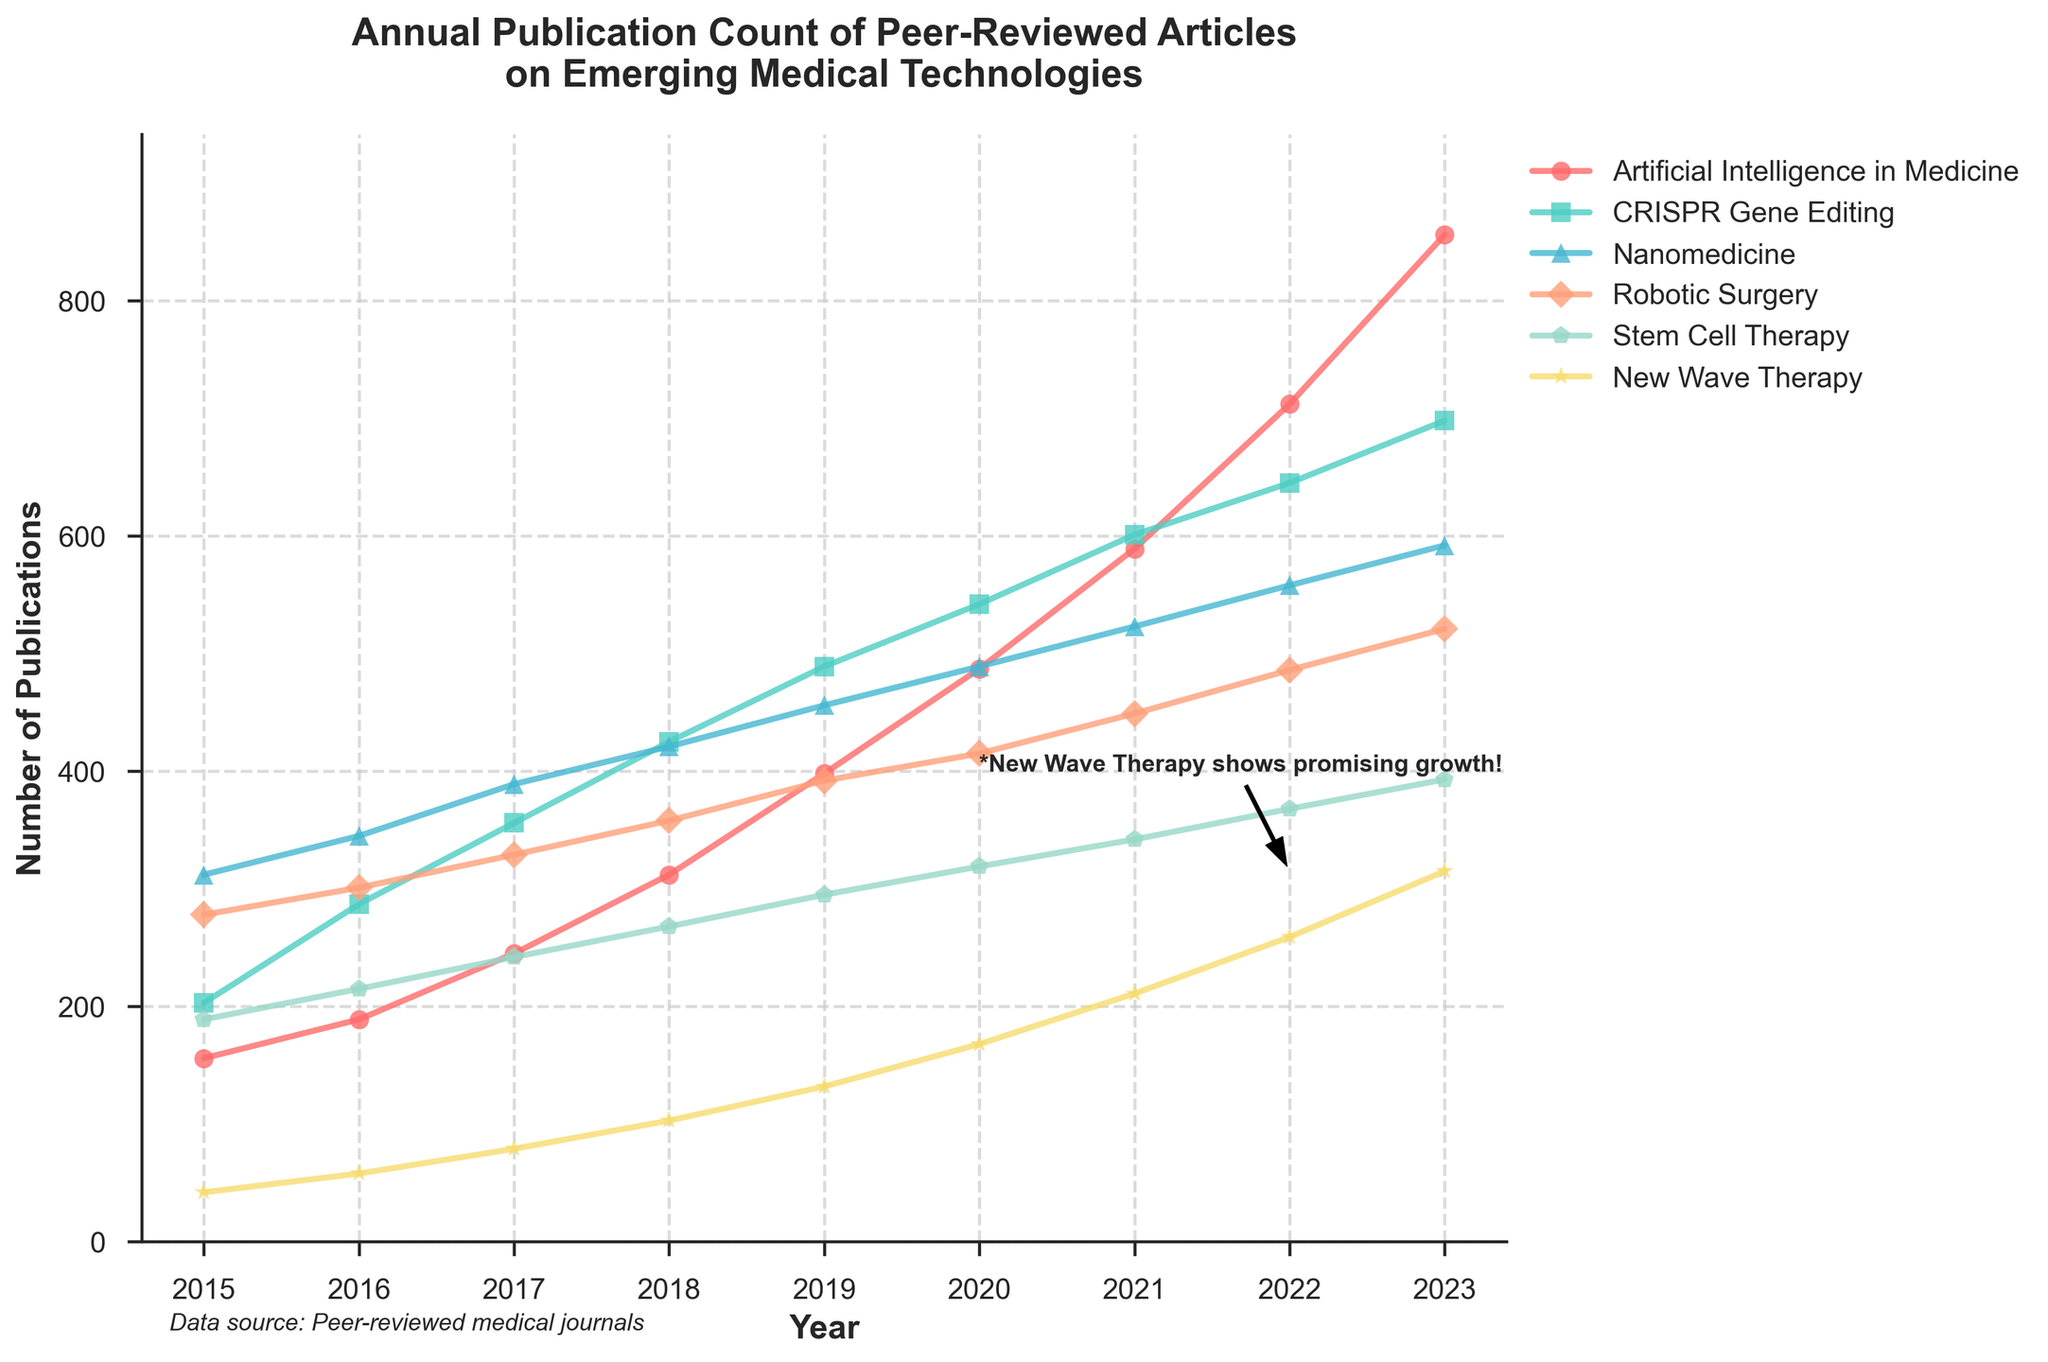What's the total number of publications in 2023 for all the technologies combined? To find the total, add the publication counts for all the technologies in the year 2023: 856 (AI in Medicine) + 698 (CRISPR) + 592 (Nanomedicine) + 521 (Robotic Surgery) + 393 (Stem Cell Therapy) + 315 (New Wave Therapy). This equates to: 856 + 698 + 592 + 521 + 393 + 315 = 3375.
Answer: 3375 Which technology had the highest increase in publications from 2015 to 2023? Calculate the increase for each technology by subtracting the 2015 count from the 2023 count:
- AI in Medicine: 856 - 156 = 700
- CRISPR: 698 - 203 = 495
- Nanomedicine: 592 - 312 = 280
- Robotic Surgery: 521 - 278 = 243
- Stem Cell Therapy: 393 - 189 = 204
- New Wave Therapy: 315 - 42 = 273
AI in Medicine had the highest increase with 700 publications.
Answer: AI in Medicine What’s the average number of publications per year for New Wave Therapy between 2015 and 2023? Sum the publication counts for New Wave Therapy from 2015 to 2023 and then divide by the number of years:
Sum = 42 + 58 + 79 + 103 + 132 + 168 + 211 + 259 + 315 = 1367
Number of years = 2023 - 2015 + 1 = 9
Average = 1367 / 9 ≈ 152
Answer: 152 During which year did Robotic Surgery first surpass 400 publications? Look at the values for Robotic Surgery year by year until it exceeds 400:
- 2015: 278
- 2016: 301
- 2017: 329
- 2018: 358
- 2019: 392
- 2020: 415 (first year with more than 400 publications)
Robotic Surgery first surpassed 400 publications in 2020.
Answer: 2020 Which technology had the most consistent publication growth from 2015 to 2023? Consistent growth can be inferred from stable and gradual increases each year without significant fluctuations. Compare the trends.
- AI in Medicine: Gradual increase each year.
- CRISPR: Similar pattern as AI in medicine.
- Nanomedicine: Similar gradual increase.
- Robotic Surgery: Gradual increase.
- Stem Cell Therapy: Gradual increase.
- New Wave Therapy: Gradual increase but less steep.
AI in Medicine shows the most consistent upward trend without major dips or significant fluctuations.
Answer: AI in Medicine How does the publication count for New Wave Therapy in 2022 compare to 2018? Note the values for New Wave Therapy in the specified years and subtract 2018 count from 2022 count:
2022: 259
2018: 103
Difference = 259 - 103 = 156
Answer: 156 In what year did CRISPR publications surpass 600? Compare the publication counts for CRISPR each year, looking for the first year it exceeds 600:
2015: 203
2016: 287
2017: 356
2018: 425
2019: 489
2020: 542
2021: 601 (just surpassed 600)
CRISPR publications first surpassed 600 in 2021.
Answer: 2021 Which technology had the lowest number of publications in 2015 and what was that number? Compare the publication counts for all technologies in 2015:
- AI in Medicine: 156
- CRISPR: 203
- Nanomedicine: 312
- Robotic Surgery: 278
- Stem Cell Therapy: 189
- New Wave Therapy: 42
New Wave Therapy had the lowest number of publications in 2015 with 42.
Answer: New Wave Therapy (42) What’s the percentage growth in publications for New Wave Therapy from 2021 to 2023? Calculate the percentage growth using the formula: 
((count in 2023 - count in 2021) / count in 2021) * 100
2021: 211
2023: 315
Percentage growth = ((315 - 211) / 211) * 100 ≈ 49.29%
Answer: 49.29% 